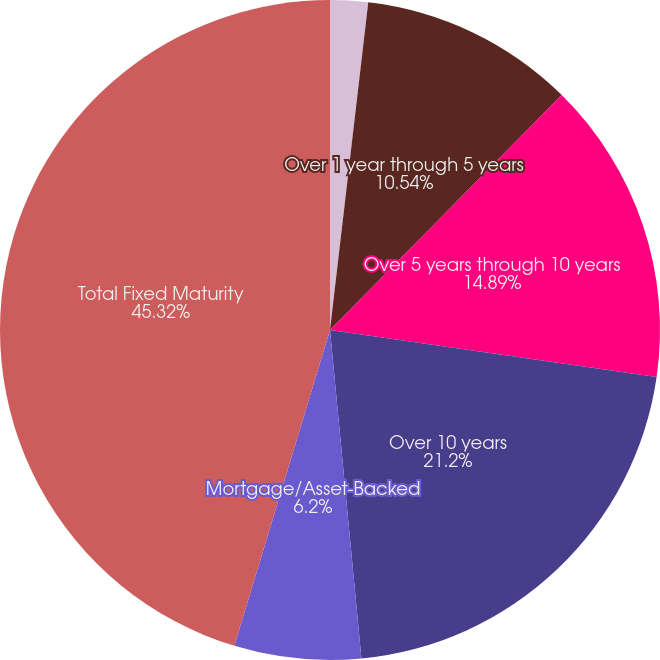<chart> <loc_0><loc_0><loc_500><loc_500><pie_chart><fcel>1 year or less<fcel>Over 1 year through 5 years<fcel>Over 5 years through 10 years<fcel>Over 10 years<fcel>Mortgage/Asset-Backed<fcel>Total Fixed Maturity<nl><fcel>1.85%<fcel>10.54%<fcel>14.89%<fcel>21.2%<fcel>6.2%<fcel>45.32%<nl></chart> 